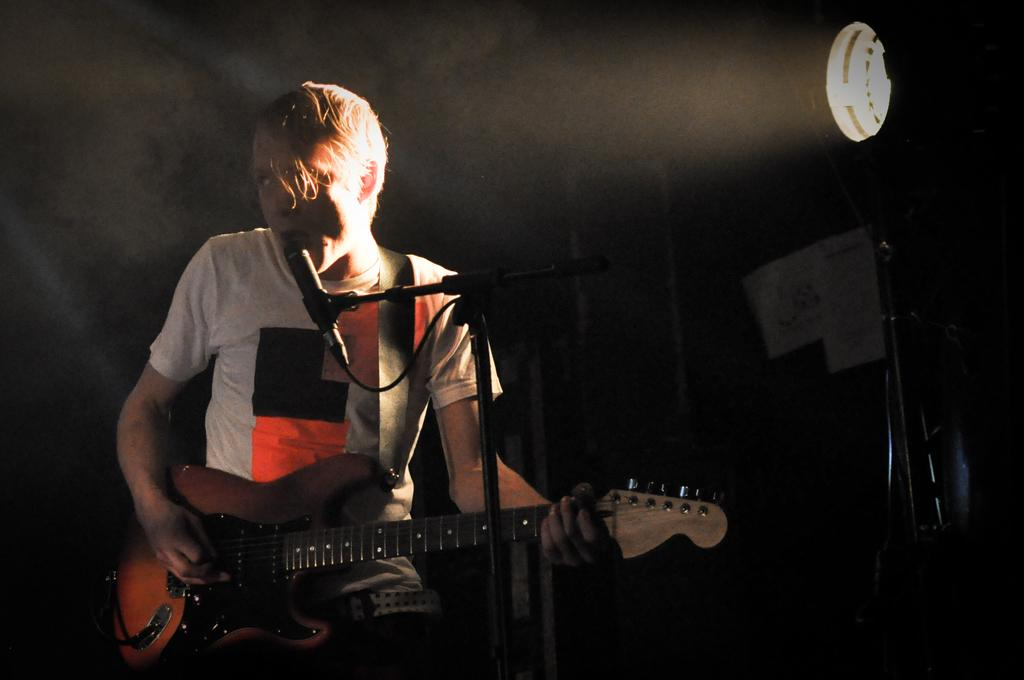Who is in the image? There is a person in the image. What is the person holding? The person is holding a guitar. What is the person standing in front of? The person is standing in front of a microphone. What can be seen in the background of the image? There is light visible in the background of the image. What type of sock is the person wearing in the image? There is no information about the person's socks in the image, so we cannot determine what type of sock they are wearing. 